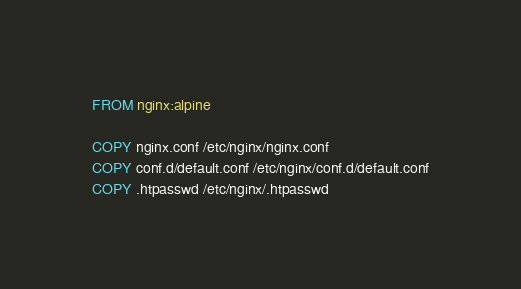Convert code to text. <code><loc_0><loc_0><loc_500><loc_500><_Dockerfile_>FROM nginx:alpine

COPY nginx.conf /etc/nginx/nginx.conf
COPY conf.d/default.conf /etc/nginx/conf.d/default.conf
COPY .htpasswd /etc/nginx/.htpasswd
</code> 